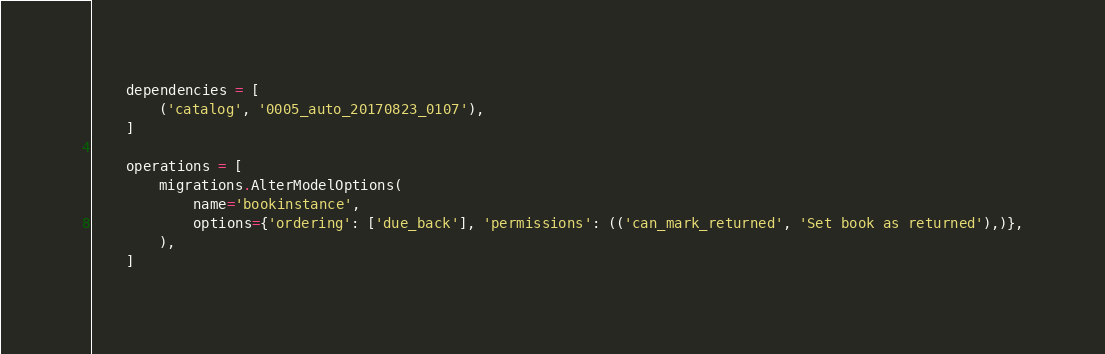Convert code to text. <code><loc_0><loc_0><loc_500><loc_500><_Python_>
    dependencies = [
        ('catalog', '0005_auto_20170823_0107'),
    ]

    operations = [
        migrations.AlterModelOptions(
            name='bookinstance',
            options={'ordering': ['due_back'], 'permissions': (('can_mark_returned', 'Set book as returned'),)},
        ),
    ]
</code> 